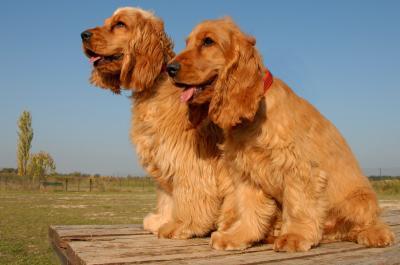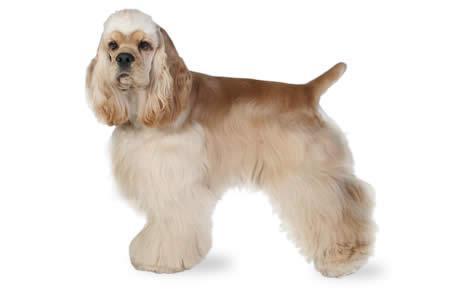The first image is the image on the left, the second image is the image on the right. Analyze the images presented: Is the assertion "the dog in the image on the left is lying down" valid? Answer yes or no. No. The first image is the image on the left, the second image is the image on the right. Evaluate the accuracy of this statement regarding the images: "The dog in the image on the left is looking toward the camera.". Is it true? Answer yes or no. No. The first image is the image on the left, the second image is the image on the right. For the images displayed, is the sentence "There is at least one extended dog tongue in one of the images." factually correct? Answer yes or no. Yes. The first image is the image on the left, the second image is the image on the right. For the images shown, is this caption "One cocker spaniel is not pictured in an outdoor setting." true? Answer yes or no. Yes. The first image is the image on the left, the second image is the image on the right. Considering the images on both sides, is "An image shows a cocker spaniel standing with its body in profile turned to the left." valid? Answer yes or no. Yes. 